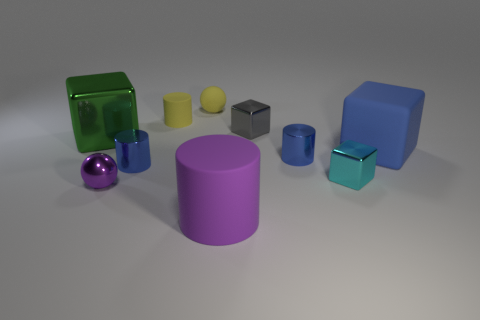Is there a large blue rubber thing that has the same shape as the small cyan thing?
Ensure brevity in your answer.  Yes. What number of other things are there of the same shape as the tiny gray metallic thing?
Give a very brief answer. 3. What is the shape of the big object that is both on the right side of the small matte ball and behind the big purple matte thing?
Your answer should be very brief. Cube. How big is the block that is left of the large purple matte object?
Your response must be concise. Large. Do the green object and the gray shiny cube have the same size?
Your answer should be very brief. No. Is the number of cubes behind the small cyan object less than the number of tiny metal objects that are left of the blue matte cube?
Keep it short and to the point. Yes. What is the size of the matte thing that is both on the left side of the tiny cyan shiny cube and in front of the gray metal cube?
Provide a short and direct response. Large. There is a rubber cylinder that is in front of the cylinder behind the green thing; is there a blue object that is left of it?
Make the answer very short. Yes. Are any tiny brown cylinders visible?
Give a very brief answer. No. Is the number of big rubber cylinders that are in front of the yellow cylinder greater than the number of small gray metallic things in front of the cyan cube?
Give a very brief answer. Yes. 